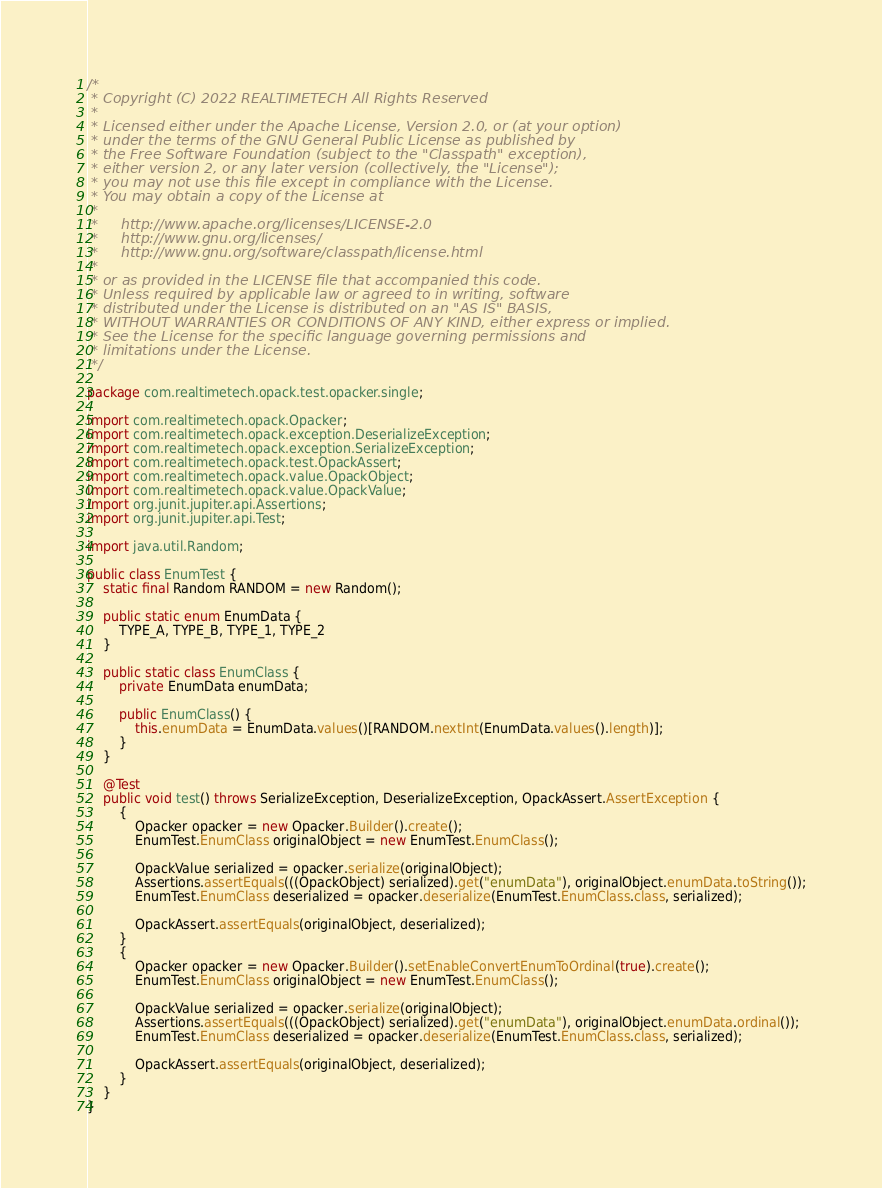Convert code to text. <code><loc_0><loc_0><loc_500><loc_500><_Java_>/*
 * Copyright (C) 2022 REALTIMETECH All Rights Reserved
 *
 * Licensed either under the Apache License, Version 2.0, or (at your option)
 * under the terms of the GNU General Public License as published by
 * the Free Software Foundation (subject to the "Classpath" exception),
 * either version 2, or any later version (collectively, the "License");
 * you may not use this file except in compliance with the License.
 * You may obtain a copy of the License at
 *
 *     http://www.apache.org/licenses/LICENSE-2.0
 *     http://www.gnu.org/licenses/
 *     http://www.gnu.org/software/classpath/license.html
 *
 * or as provided in the LICENSE file that accompanied this code.
 * Unless required by applicable law or agreed to in writing, software
 * distributed under the License is distributed on an "AS IS" BASIS,
 * WITHOUT WARRANTIES OR CONDITIONS OF ANY KIND, either express or implied.
 * See the License for the specific language governing permissions and
 * limitations under the License.
 */

package com.realtimetech.opack.test.opacker.single;

import com.realtimetech.opack.Opacker;
import com.realtimetech.opack.exception.DeserializeException;
import com.realtimetech.opack.exception.SerializeException;
import com.realtimetech.opack.test.OpackAssert;
import com.realtimetech.opack.value.OpackObject;
import com.realtimetech.opack.value.OpackValue;
import org.junit.jupiter.api.Assertions;
import org.junit.jupiter.api.Test;

import java.util.Random;

public class EnumTest {
    static final Random RANDOM = new Random();

    public static enum EnumData {
        TYPE_A, TYPE_B, TYPE_1, TYPE_2
    }

    public static class EnumClass {
        private EnumData enumData;

        public EnumClass() {
            this.enumData = EnumData.values()[RANDOM.nextInt(EnumData.values().length)];
        }
    }

    @Test
    public void test() throws SerializeException, DeserializeException, OpackAssert.AssertException {
        {
            Opacker opacker = new Opacker.Builder().create();
            EnumTest.EnumClass originalObject = new EnumTest.EnumClass();

            OpackValue serialized = opacker.serialize(originalObject);
            Assertions.assertEquals(((OpackObject) serialized).get("enumData"), originalObject.enumData.toString());
            EnumTest.EnumClass deserialized = opacker.deserialize(EnumTest.EnumClass.class, serialized);

            OpackAssert.assertEquals(originalObject, deserialized);
        }
        {
            Opacker opacker = new Opacker.Builder().setEnableConvertEnumToOrdinal(true).create();
            EnumTest.EnumClass originalObject = new EnumTest.EnumClass();

            OpackValue serialized = opacker.serialize(originalObject);
            Assertions.assertEquals(((OpackObject) serialized).get("enumData"), originalObject.enumData.ordinal());
            EnumTest.EnumClass deserialized = opacker.deserialize(EnumTest.EnumClass.class, serialized);

            OpackAssert.assertEquals(originalObject, deserialized);
        }
    }
}
</code> 